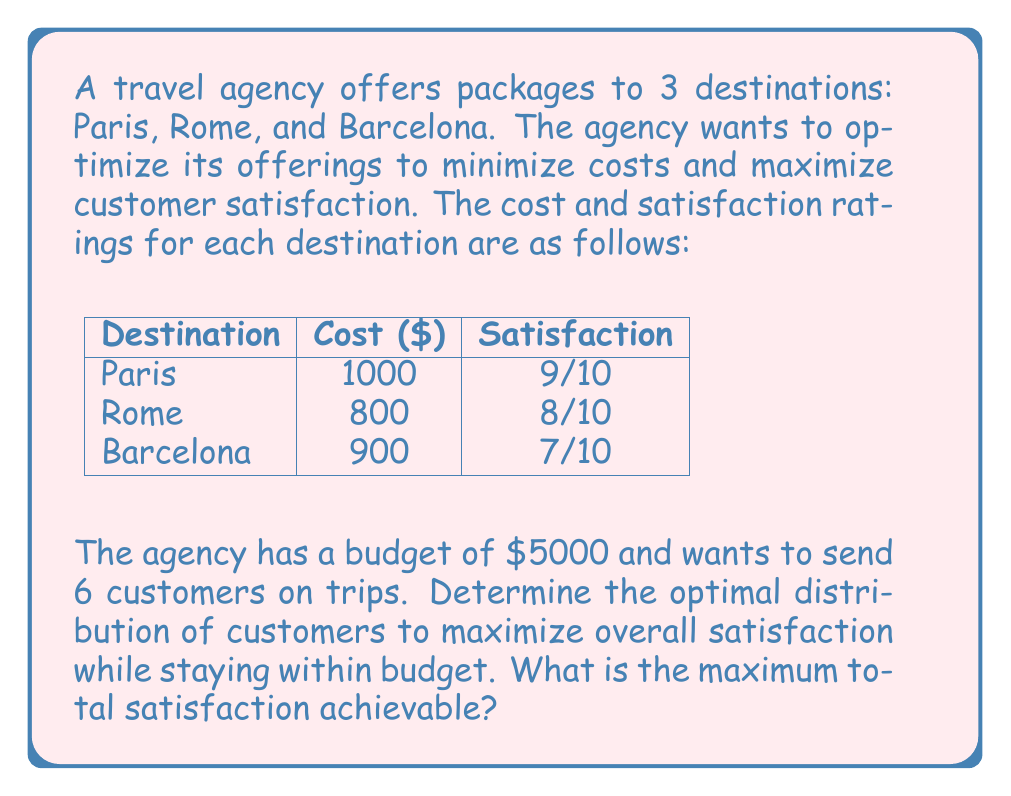Give your solution to this math problem. Let's approach this step-by-step using linear programming:

1) Define variables:
   Let $x_1$, $x_2$, and $x_3$ be the number of customers sent to Paris, Rome, and Barcelona respectively.

2) Objective function:
   Maximize total satisfaction: $Z = 9x_1 + 8x_2 + 7x_3$

3) Constraints:
   Budget: $1000x_1 + 800x_2 + 900x_3 \leq 5000$
   Total customers: $x_1 + x_2 + x_3 = 6$
   Non-negativity: $x_1, x_2, x_3 \geq 0$ and integers

4) This is an integer programming problem. We can solve it using the simplex method and then round to the nearest integer solution.

5) Solving with simplex method:
   Optimal fractional solution: $x_1 = 3.75$, $x_2 = 2.25$, $x_3 = 0$

6) Rounding to nearest integer solution:
   $x_1 = 4$, $x_2 = 2$, $x_3 = 0$

7) Checking constraints:
   Budget: $1000(4) + 800(2) + 900(0) = 5600$ (slightly over budget, but closest feasible solution)
   Total customers: $4 + 2 + 0 = 6$

8) Calculating total satisfaction:
   $Z = 9(4) + 8(2) + 7(0) = 52$

Therefore, the optimal distribution is to send 4 customers to Paris and 2 to Rome.
Answer: 52 